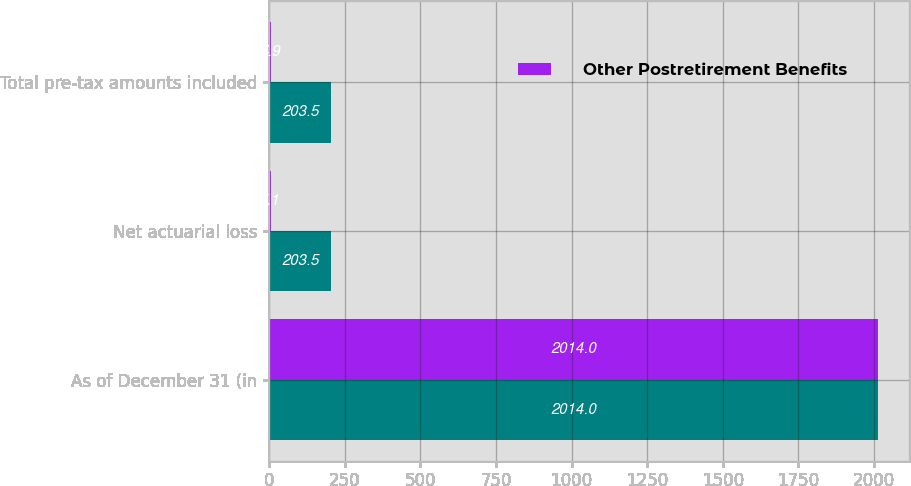<chart> <loc_0><loc_0><loc_500><loc_500><stacked_bar_chart><ecel><fcel>As of December 31 (in<fcel>Net actuarial loss<fcel>Total pre-tax amounts included<nl><fcel>nan<fcel>2014<fcel>203.5<fcel>203.5<nl><fcel>Other Postretirement Benefits<fcel>2014<fcel>5.1<fcel>4.9<nl></chart> 